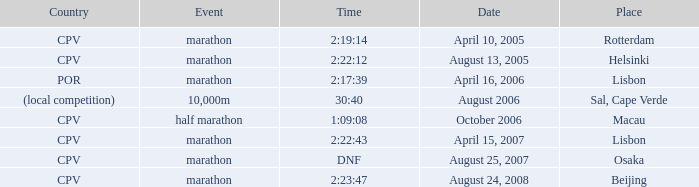What is the Country of the 10,000m Event? (local competition). 